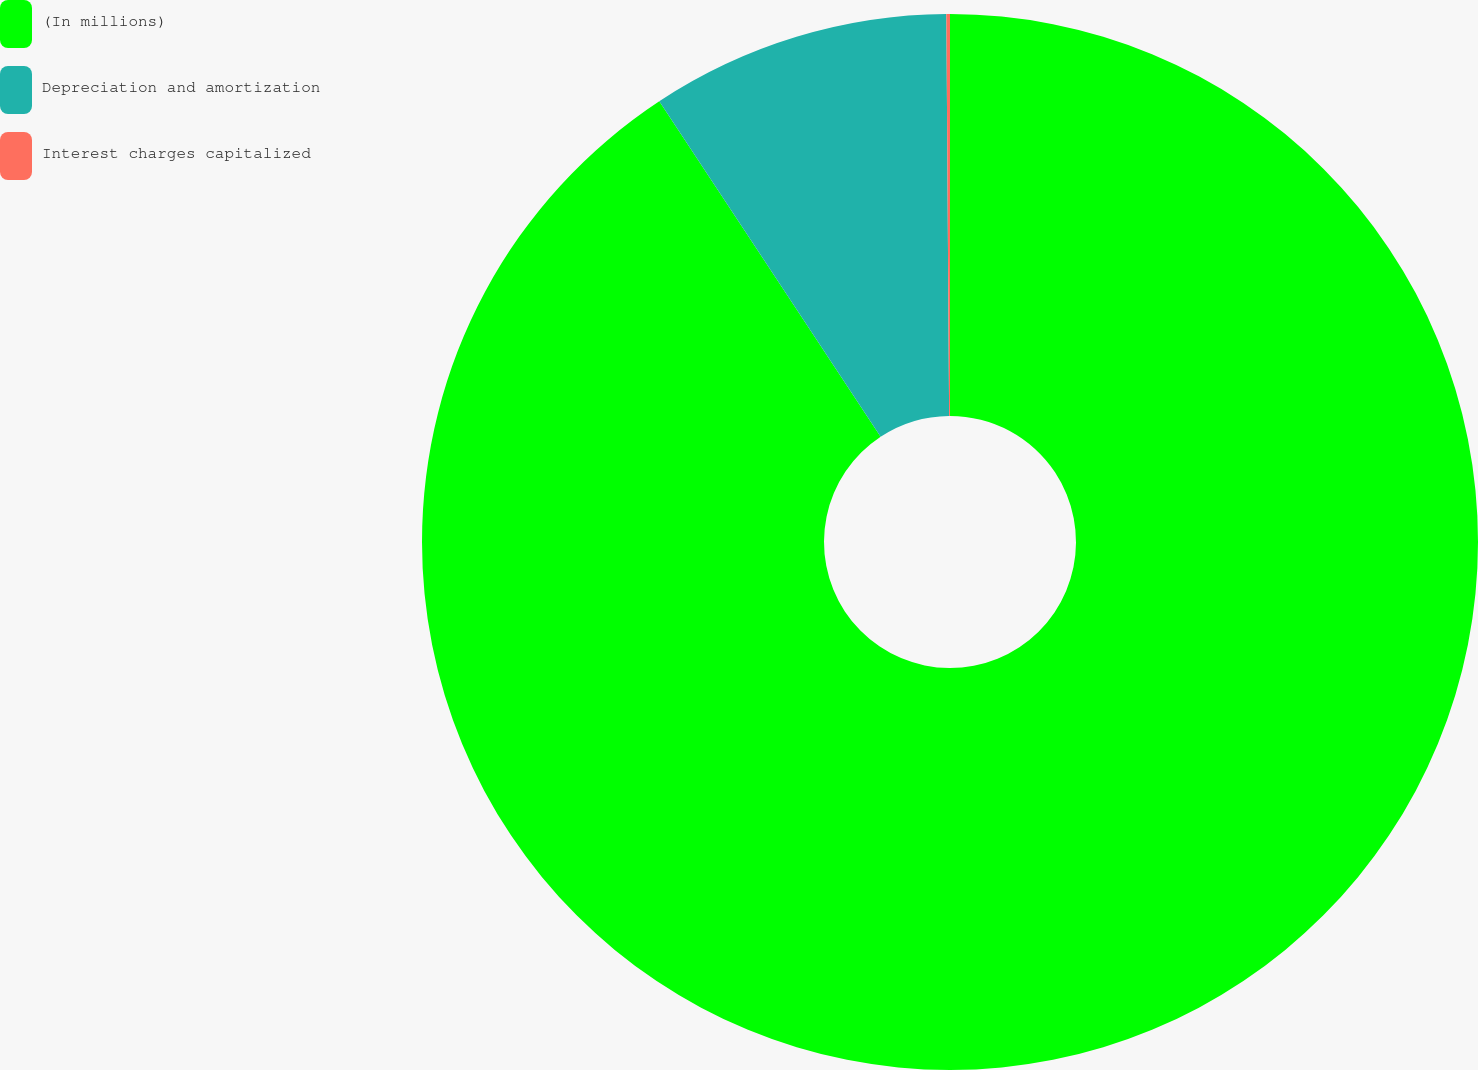Convert chart. <chart><loc_0><loc_0><loc_500><loc_500><pie_chart><fcel>(In millions)<fcel>Depreciation and amortization<fcel>Interest charges capitalized<nl><fcel>90.72%<fcel>9.17%<fcel>0.11%<nl></chart> 